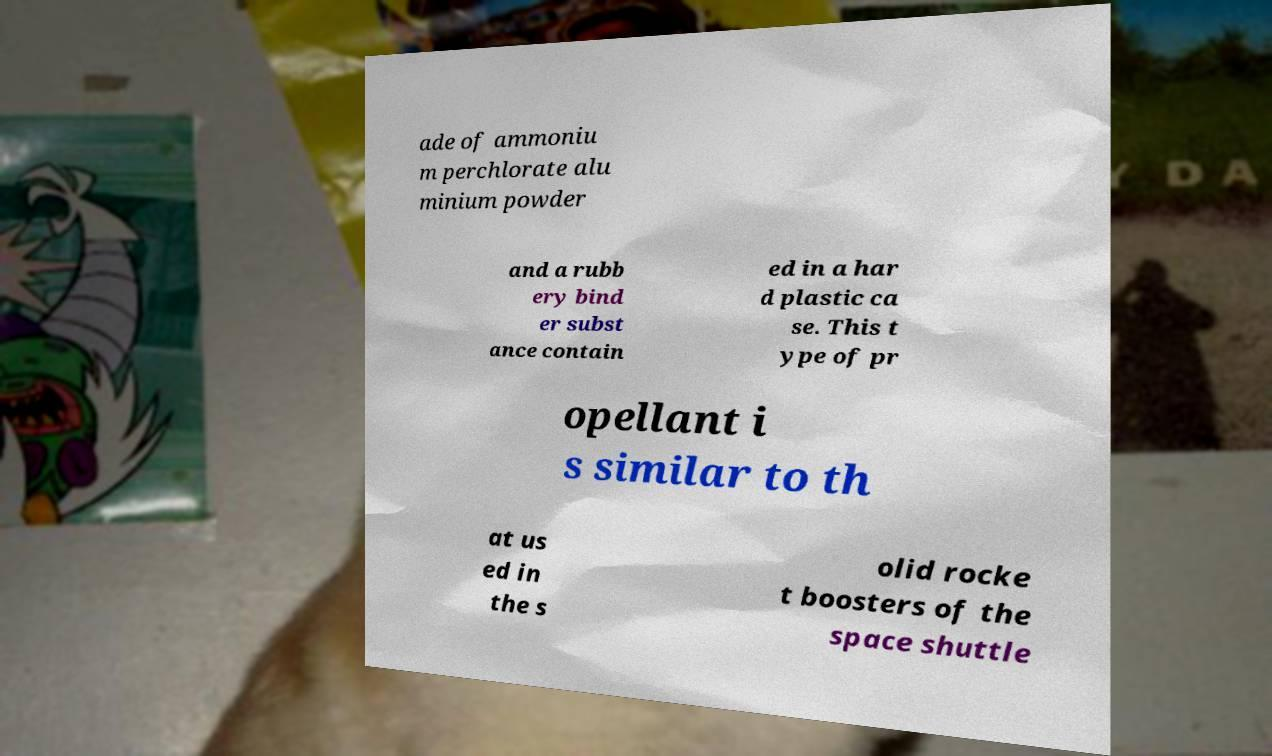Can you accurately transcribe the text from the provided image for me? ade of ammoniu m perchlorate alu minium powder and a rubb ery bind er subst ance contain ed in a har d plastic ca se. This t ype of pr opellant i s similar to th at us ed in the s olid rocke t boosters of the space shuttle 